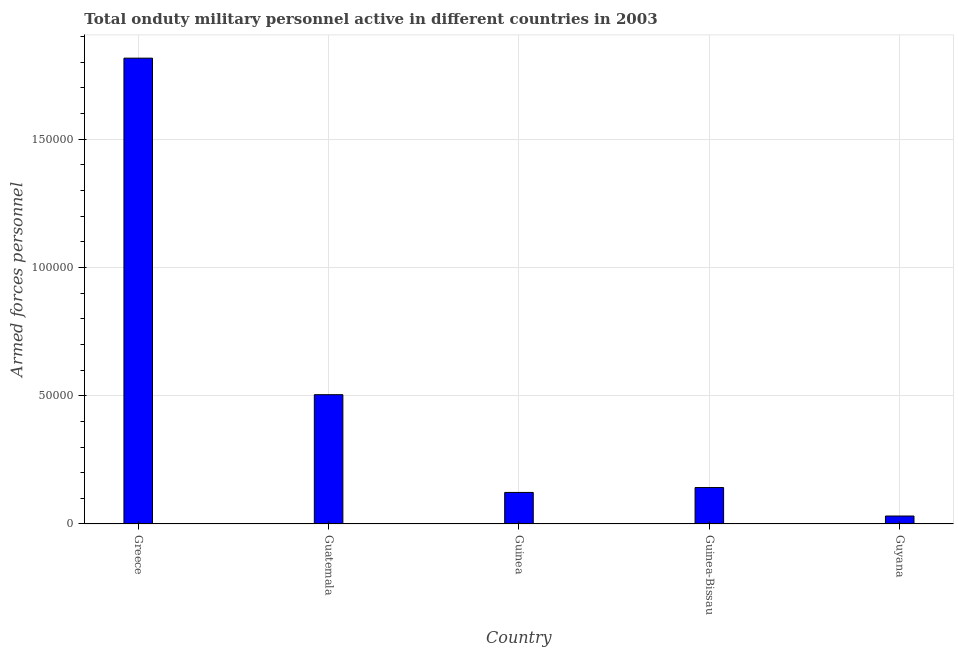Does the graph contain grids?
Offer a very short reply. Yes. What is the title of the graph?
Make the answer very short. Total onduty military personnel active in different countries in 2003. What is the label or title of the Y-axis?
Provide a short and direct response. Armed forces personnel. What is the number of armed forces personnel in Guyana?
Provide a short and direct response. 3100. Across all countries, what is the maximum number of armed forces personnel?
Offer a terse response. 1.82e+05. Across all countries, what is the minimum number of armed forces personnel?
Your response must be concise. 3100. In which country was the number of armed forces personnel maximum?
Your answer should be compact. Greece. In which country was the number of armed forces personnel minimum?
Provide a short and direct response. Guyana. What is the sum of the number of armed forces personnel?
Ensure brevity in your answer.  2.62e+05. What is the difference between the number of armed forces personnel in Greece and Guatemala?
Offer a very short reply. 1.31e+05. What is the average number of armed forces personnel per country?
Provide a succinct answer. 5.23e+04. What is the median number of armed forces personnel?
Keep it short and to the point. 1.42e+04. What is the ratio of the number of armed forces personnel in Guatemala to that in Guinea-Bissau?
Your answer should be very brief. 3.55. Is the number of armed forces personnel in Guatemala less than that in Guinea?
Provide a short and direct response. No. What is the difference between the highest and the second highest number of armed forces personnel?
Your answer should be very brief. 1.31e+05. Is the sum of the number of armed forces personnel in Greece and Guinea greater than the maximum number of armed forces personnel across all countries?
Your answer should be very brief. Yes. What is the difference between the highest and the lowest number of armed forces personnel?
Provide a short and direct response. 1.78e+05. In how many countries, is the number of armed forces personnel greater than the average number of armed forces personnel taken over all countries?
Provide a short and direct response. 1. Are all the bars in the graph horizontal?
Your answer should be compact. No. What is the Armed forces personnel in Greece?
Your answer should be compact. 1.82e+05. What is the Armed forces personnel of Guatemala?
Your answer should be very brief. 5.04e+04. What is the Armed forces personnel in Guinea?
Your response must be concise. 1.23e+04. What is the Armed forces personnel of Guinea-Bissau?
Give a very brief answer. 1.42e+04. What is the Armed forces personnel of Guyana?
Make the answer very short. 3100. What is the difference between the Armed forces personnel in Greece and Guatemala?
Offer a very short reply. 1.31e+05. What is the difference between the Armed forces personnel in Greece and Guinea?
Make the answer very short. 1.69e+05. What is the difference between the Armed forces personnel in Greece and Guinea-Bissau?
Your answer should be compact. 1.67e+05. What is the difference between the Armed forces personnel in Greece and Guyana?
Offer a terse response. 1.78e+05. What is the difference between the Armed forces personnel in Guatemala and Guinea?
Provide a short and direct response. 3.81e+04. What is the difference between the Armed forces personnel in Guatemala and Guinea-Bissau?
Provide a succinct answer. 3.62e+04. What is the difference between the Armed forces personnel in Guatemala and Guyana?
Provide a succinct answer. 4.73e+04. What is the difference between the Armed forces personnel in Guinea and Guinea-Bissau?
Your response must be concise. -1900. What is the difference between the Armed forces personnel in Guinea and Guyana?
Provide a short and direct response. 9200. What is the difference between the Armed forces personnel in Guinea-Bissau and Guyana?
Your answer should be very brief. 1.11e+04. What is the ratio of the Armed forces personnel in Greece to that in Guatemala?
Your answer should be very brief. 3.6. What is the ratio of the Armed forces personnel in Greece to that in Guinea?
Provide a succinct answer. 14.76. What is the ratio of the Armed forces personnel in Greece to that in Guinea-Bissau?
Your answer should be compact. 12.79. What is the ratio of the Armed forces personnel in Greece to that in Guyana?
Your answer should be compact. 58.58. What is the ratio of the Armed forces personnel in Guatemala to that in Guinea?
Your answer should be very brief. 4.1. What is the ratio of the Armed forces personnel in Guatemala to that in Guinea-Bissau?
Provide a succinct answer. 3.55. What is the ratio of the Armed forces personnel in Guatemala to that in Guyana?
Your answer should be compact. 16.26. What is the ratio of the Armed forces personnel in Guinea to that in Guinea-Bissau?
Provide a succinct answer. 0.87. What is the ratio of the Armed forces personnel in Guinea to that in Guyana?
Offer a very short reply. 3.97. What is the ratio of the Armed forces personnel in Guinea-Bissau to that in Guyana?
Offer a very short reply. 4.58. 